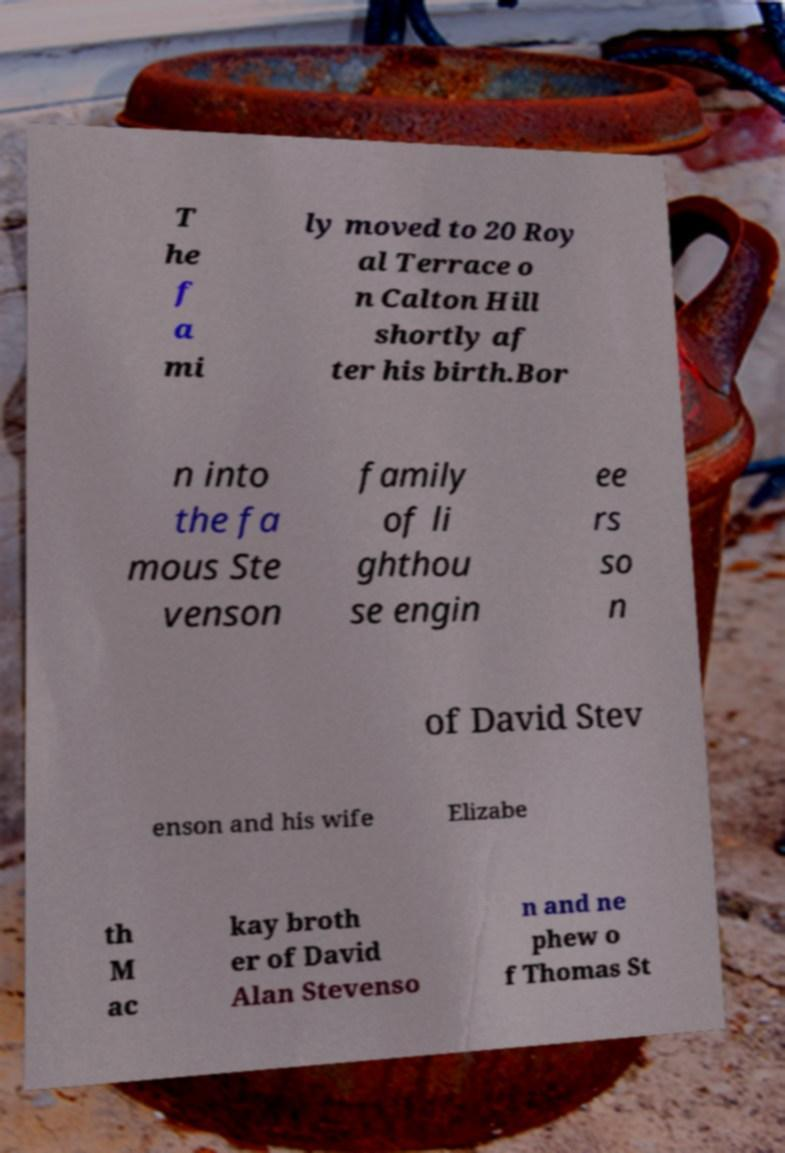Could you extract and type out the text from this image? T he f a mi ly moved to 20 Roy al Terrace o n Calton Hill shortly af ter his birth.Bor n into the fa mous Ste venson family of li ghthou se engin ee rs so n of David Stev enson and his wife Elizabe th M ac kay broth er of David Alan Stevenso n and ne phew o f Thomas St 